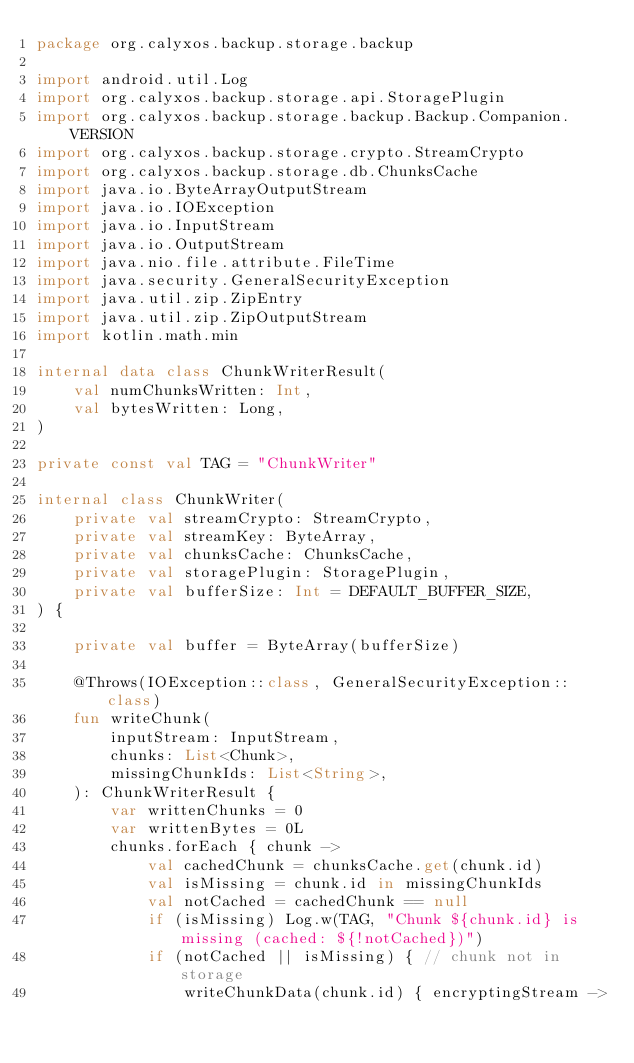<code> <loc_0><loc_0><loc_500><loc_500><_Kotlin_>package org.calyxos.backup.storage.backup

import android.util.Log
import org.calyxos.backup.storage.api.StoragePlugin
import org.calyxos.backup.storage.backup.Backup.Companion.VERSION
import org.calyxos.backup.storage.crypto.StreamCrypto
import org.calyxos.backup.storage.db.ChunksCache
import java.io.ByteArrayOutputStream
import java.io.IOException
import java.io.InputStream
import java.io.OutputStream
import java.nio.file.attribute.FileTime
import java.security.GeneralSecurityException
import java.util.zip.ZipEntry
import java.util.zip.ZipOutputStream
import kotlin.math.min

internal data class ChunkWriterResult(
    val numChunksWritten: Int,
    val bytesWritten: Long,
)

private const val TAG = "ChunkWriter"

internal class ChunkWriter(
    private val streamCrypto: StreamCrypto,
    private val streamKey: ByteArray,
    private val chunksCache: ChunksCache,
    private val storagePlugin: StoragePlugin,
    private val bufferSize: Int = DEFAULT_BUFFER_SIZE,
) {

    private val buffer = ByteArray(bufferSize)

    @Throws(IOException::class, GeneralSecurityException::class)
    fun writeChunk(
        inputStream: InputStream,
        chunks: List<Chunk>,
        missingChunkIds: List<String>,
    ): ChunkWriterResult {
        var writtenChunks = 0
        var writtenBytes = 0L
        chunks.forEach { chunk ->
            val cachedChunk = chunksCache.get(chunk.id)
            val isMissing = chunk.id in missingChunkIds
            val notCached = cachedChunk == null
            if (isMissing) Log.w(TAG, "Chunk ${chunk.id} is missing (cached: ${!notCached})")
            if (notCached || isMissing) { // chunk not in storage
                writeChunkData(chunk.id) { encryptingStream -></code> 